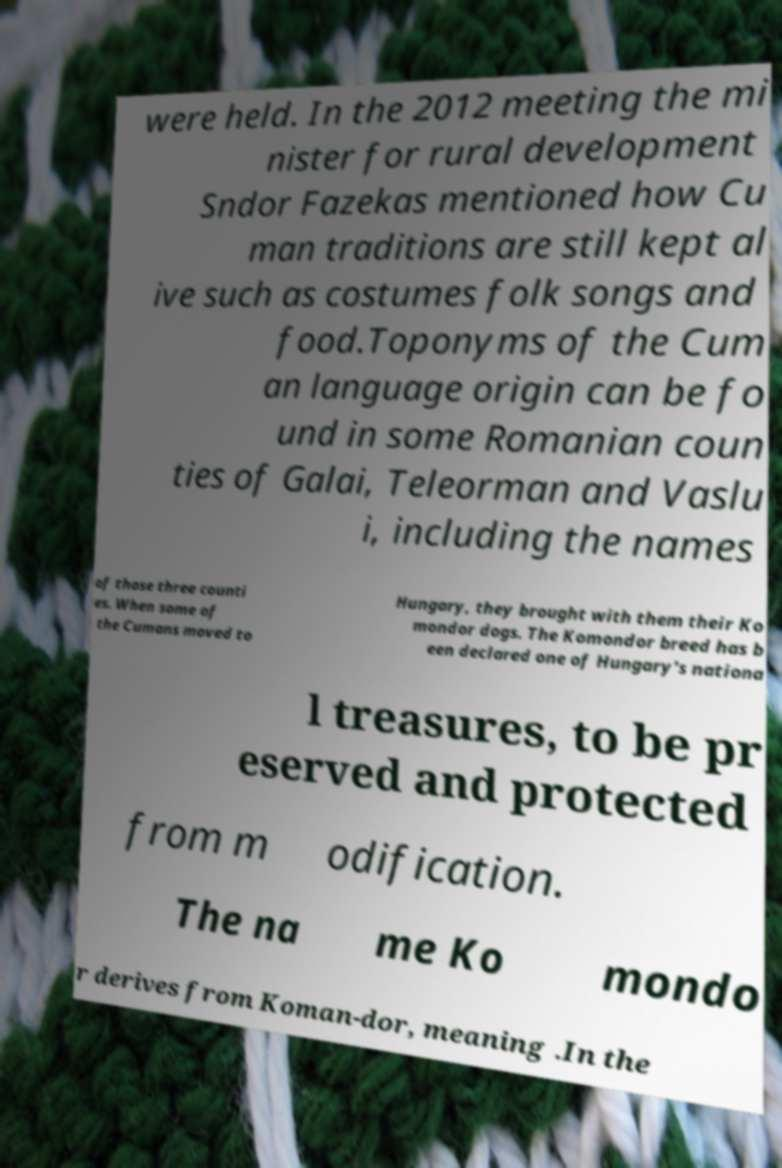Can you read and provide the text displayed in the image?This photo seems to have some interesting text. Can you extract and type it out for me? were held. In the 2012 meeting the mi nister for rural development Sndor Fazekas mentioned how Cu man traditions are still kept al ive such as costumes folk songs and food.Toponyms of the Cum an language origin can be fo und in some Romanian coun ties of Galai, Teleorman and Vaslu i, including the names of those three counti es. When some of the Cumans moved to Hungary, they brought with them their Ko mondor dogs. The Komondor breed has b een declared one of Hungary's nationa l treasures, to be pr eserved and protected from m odification. The na me Ko mondo r derives from Koman-dor, meaning .In the 